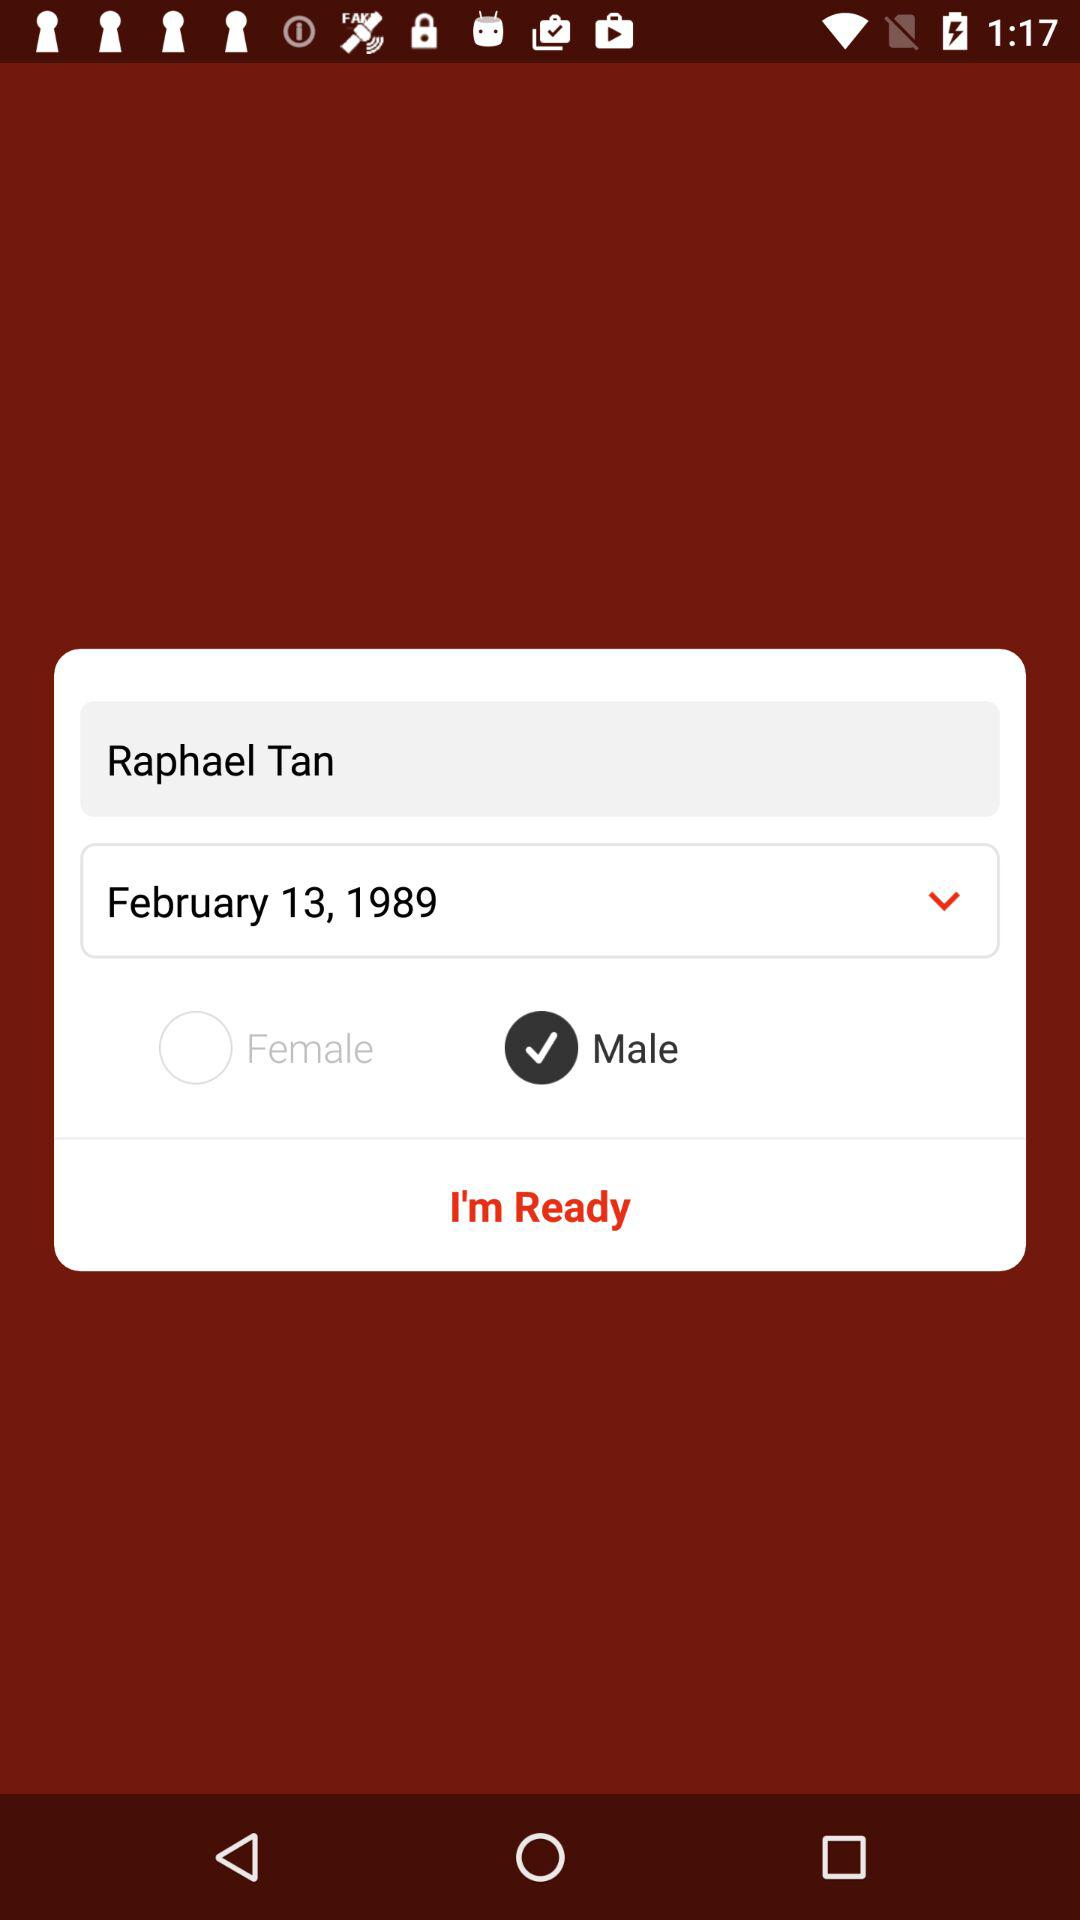When was the user born? The user was born on February 13, 1989. 